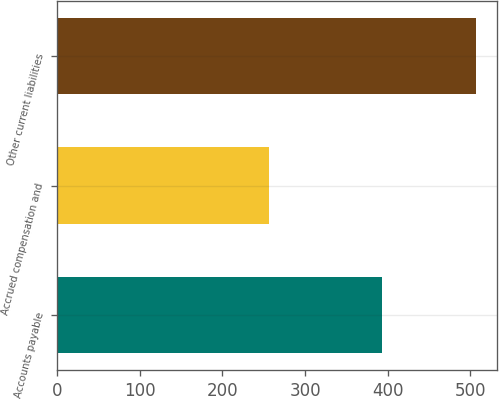Convert chart to OTSL. <chart><loc_0><loc_0><loc_500><loc_500><bar_chart><fcel>Accounts payable<fcel>Accrued compensation and<fcel>Other current liabilities<nl><fcel>393<fcel>257<fcel>507<nl></chart> 